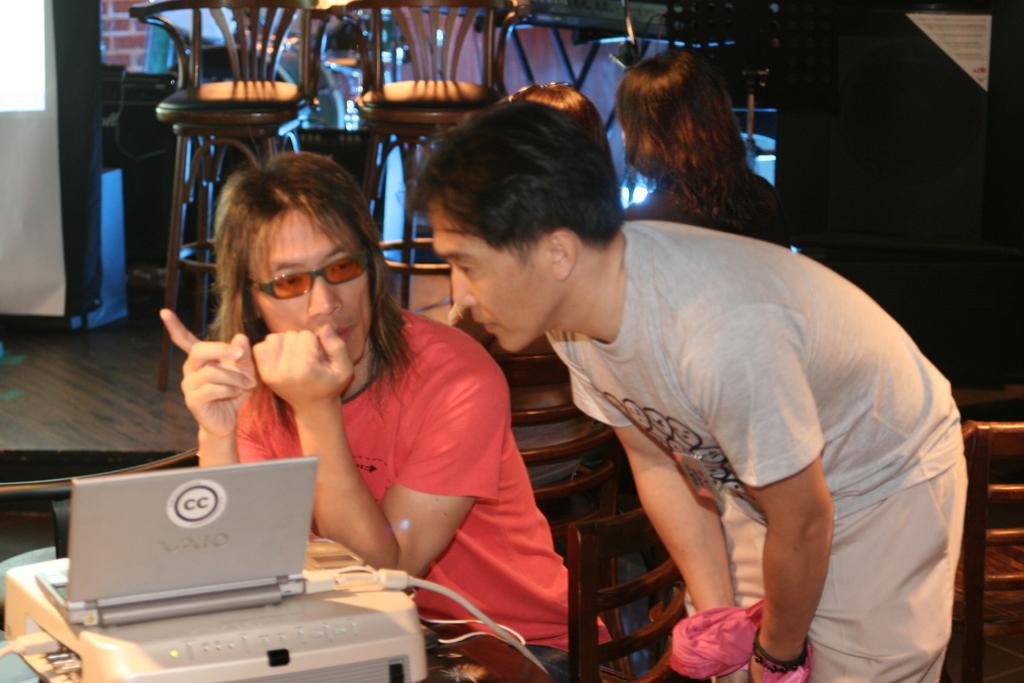Provide a one-sentence caption for the provided image. A small silver laptop with CC on the lid sits in front of a man in red. 